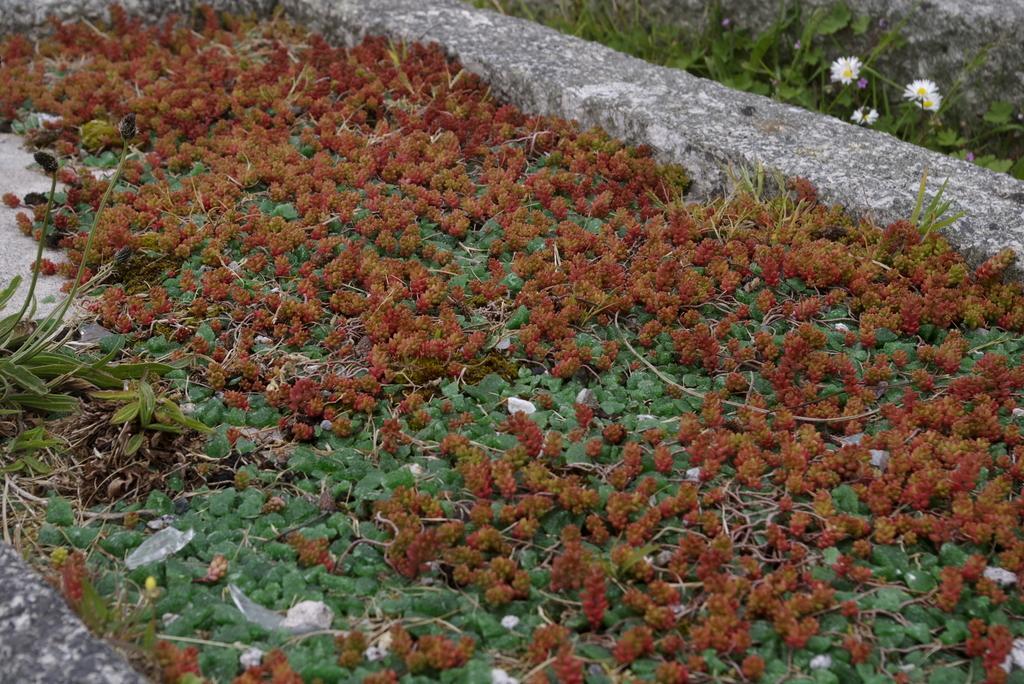How would you summarize this image in a sentence or two? In the foreground we can see grass with green color leaves and red color flowers. On the top right side, we can see white color flowers and grass. We can see small wall. On the left side, we can see green color grass with two petals. 